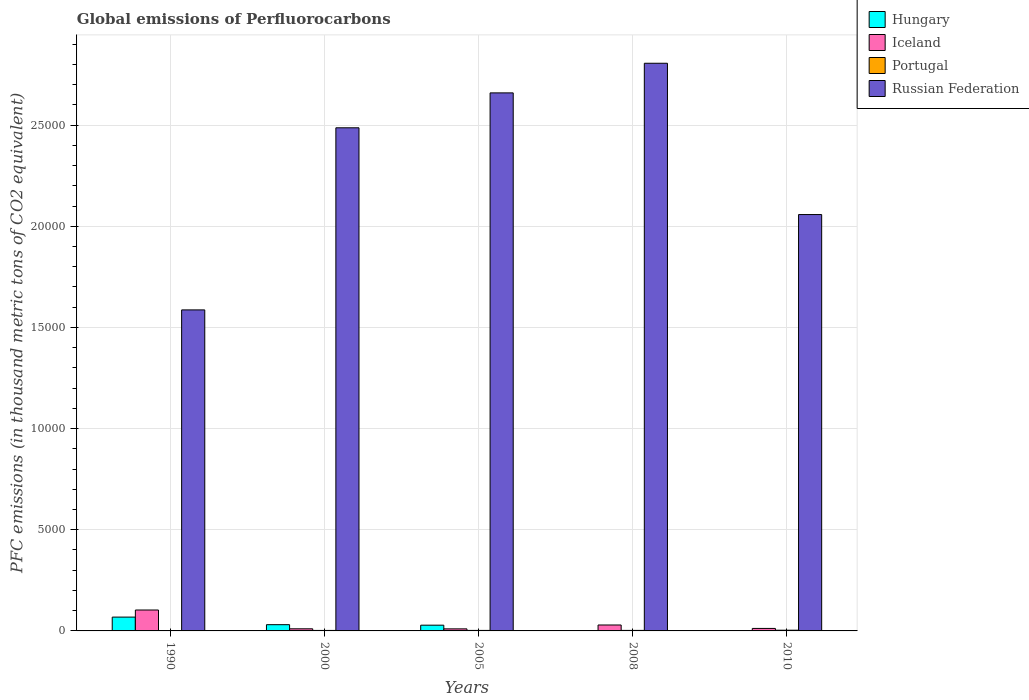How many different coloured bars are there?
Your answer should be compact. 4. How many groups of bars are there?
Offer a terse response. 5. Are the number of bars on each tick of the X-axis equal?
Your response must be concise. Yes. What is the label of the 1st group of bars from the left?
Offer a very short reply. 1990. In how many cases, is the number of bars for a given year not equal to the number of legend labels?
Keep it short and to the point. 0. What is the global emissions of Perfluorocarbons in Portugal in 2005?
Your answer should be very brief. 25.4. Across all years, what is the maximum global emissions of Perfluorocarbons in Russian Federation?
Your response must be concise. 2.81e+04. Across all years, what is the minimum global emissions of Perfluorocarbons in Iceland?
Your answer should be very brief. 101.6. In which year was the global emissions of Perfluorocarbons in Portugal maximum?
Your answer should be compact. 2010. What is the total global emissions of Perfluorocarbons in Russian Federation in the graph?
Provide a succinct answer. 1.16e+05. What is the difference between the global emissions of Perfluorocarbons in Hungary in 2000 and that in 2008?
Give a very brief answer. 305.8. What is the difference between the global emissions of Perfluorocarbons in Iceland in 2000 and the global emissions of Perfluorocarbons in Hungary in 2008?
Your response must be concise. 101.9. What is the average global emissions of Perfluorocarbons in Hungary per year?
Provide a succinct answer. 256.24. In the year 1990, what is the difference between the global emissions of Perfluorocarbons in Iceland and global emissions of Perfluorocarbons in Russian Federation?
Offer a terse response. -1.48e+04. What is the ratio of the global emissions of Perfluorocarbons in Iceland in 2000 to that in 2010?
Provide a short and direct response. 0.85. Is the global emissions of Perfluorocarbons in Hungary in 1990 less than that in 2008?
Offer a terse response. No. Is the difference between the global emissions of Perfluorocarbons in Iceland in 1990 and 2005 greater than the difference between the global emissions of Perfluorocarbons in Russian Federation in 1990 and 2005?
Give a very brief answer. Yes. What is the difference between the highest and the second highest global emissions of Perfluorocarbons in Iceland?
Make the answer very short. 740.7. What is the difference between the highest and the lowest global emissions of Perfluorocarbons in Portugal?
Provide a succinct answer. 32.4. What does the 4th bar from the right in 2005 represents?
Offer a terse response. Hungary. Is it the case that in every year, the sum of the global emissions of Perfluorocarbons in Russian Federation and global emissions of Perfluorocarbons in Iceland is greater than the global emissions of Perfluorocarbons in Hungary?
Offer a very short reply. Yes. How many bars are there?
Your response must be concise. 20. Are all the bars in the graph horizontal?
Your response must be concise. No. Are the values on the major ticks of Y-axis written in scientific E-notation?
Give a very brief answer. No. Does the graph contain any zero values?
Your answer should be very brief. No. Does the graph contain grids?
Offer a terse response. Yes. How many legend labels are there?
Give a very brief answer. 4. How are the legend labels stacked?
Provide a short and direct response. Vertical. What is the title of the graph?
Provide a short and direct response. Global emissions of Perfluorocarbons. What is the label or title of the Y-axis?
Provide a succinct answer. PFC emissions (in thousand metric tons of CO2 equivalent). What is the PFC emissions (in thousand metric tons of CO2 equivalent) in Hungary in 1990?
Provide a short and direct response. 683.3. What is the PFC emissions (in thousand metric tons of CO2 equivalent) of Iceland in 1990?
Your response must be concise. 1033.4. What is the PFC emissions (in thousand metric tons of CO2 equivalent) of Russian Federation in 1990?
Provide a succinct answer. 1.59e+04. What is the PFC emissions (in thousand metric tons of CO2 equivalent) in Hungary in 2000?
Offer a very short reply. 308.5. What is the PFC emissions (in thousand metric tons of CO2 equivalent) in Iceland in 2000?
Your answer should be very brief. 104.6. What is the PFC emissions (in thousand metric tons of CO2 equivalent) in Portugal in 2000?
Your answer should be very brief. 24.6. What is the PFC emissions (in thousand metric tons of CO2 equivalent) of Russian Federation in 2000?
Your answer should be very brief. 2.49e+04. What is the PFC emissions (in thousand metric tons of CO2 equivalent) in Hungary in 2005?
Your answer should be very brief. 283.7. What is the PFC emissions (in thousand metric tons of CO2 equivalent) in Iceland in 2005?
Offer a terse response. 101.6. What is the PFC emissions (in thousand metric tons of CO2 equivalent) in Portugal in 2005?
Provide a short and direct response. 25.4. What is the PFC emissions (in thousand metric tons of CO2 equivalent) in Russian Federation in 2005?
Your answer should be very brief. 2.66e+04. What is the PFC emissions (in thousand metric tons of CO2 equivalent) in Hungary in 2008?
Provide a succinct answer. 2.7. What is the PFC emissions (in thousand metric tons of CO2 equivalent) of Iceland in 2008?
Make the answer very short. 292.7. What is the PFC emissions (in thousand metric tons of CO2 equivalent) in Portugal in 2008?
Your answer should be compact. 25.9. What is the PFC emissions (in thousand metric tons of CO2 equivalent) in Russian Federation in 2008?
Your answer should be very brief. 2.81e+04. What is the PFC emissions (in thousand metric tons of CO2 equivalent) in Iceland in 2010?
Your answer should be compact. 123. What is the PFC emissions (in thousand metric tons of CO2 equivalent) of Russian Federation in 2010?
Your answer should be compact. 2.06e+04. Across all years, what is the maximum PFC emissions (in thousand metric tons of CO2 equivalent) in Hungary?
Provide a succinct answer. 683.3. Across all years, what is the maximum PFC emissions (in thousand metric tons of CO2 equivalent) in Iceland?
Your answer should be very brief. 1033.4. Across all years, what is the maximum PFC emissions (in thousand metric tons of CO2 equivalent) of Portugal?
Provide a short and direct response. 35. Across all years, what is the maximum PFC emissions (in thousand metric tons of CO2 equivalent) in Russian Federation?
Give a very brief answer. 2.81e+04. Across all years, what is the minimum PFC emissions (in thousand metric tons of CO2 equivalent) of Hungary?
Offer a very short reply. 2.7. Across all years, what is the minimum PFC emissions (in thousand metric tons of CO2 equivalent) of Iceland?
Your response must be concise. 101.6. Across all years, what is the minimum PFC emissions (in thousand metric tons of CO2 equivalent) in Portugal?
Make the answer very short. 2.6. Across all years, what is the minimum PFC emissions (in thousand metric tons of CO2 equivalent) of Russian Federation?
Give a very brief answer. 1.59e+04. What is the total PFC emissions (in thousand metric tons of CO2 equivalent) in Hungary in the graph?
Make the answer very short. 1281.2. What is the total PFC emissions (in thousand metric tons of CO2 equivalent) of Iceland in the graph?
Offer a very short reply. 1655.3. What is the total PFC emissions (in thousand metric tons of CO2 equivalent) of Portugal in the graph?
Ensure brevity in your answer.  113.5. What is the total PFC emissions (in thousand metric tons of CO2 equivalent) of Russian Federation in the graph?
Offer a terse response. 1.16e+05. What is the difference between the PFC emissions (in thousand metric tons of CO2 equivalent) in Hungary in 1990 and that in 2000?
Make the answer very short. 374.8. What is the difference between the PFC emissions (in thousand metric tons of CO2 equivalent) in Iceland in 1990 and that in 2000?
Ensure brevity in your answer.  928.8. What is the difference between the PFC emissions (in thousand metric tons of CO2 equivalent) of Portugal in 1990 and that in 2000?
Make the answer very short. -22. What is the difference between the PFC emissions (in thousand metric tons of CO2 equivalent) of Russian Federation in 1990 and that in 2000?
Your answer should be very brief. -8999.9. What is the difference between the PFC emissions (in thousand metric tons of CO2 equivalent) in Hungary in 1990 and that in 2005?
Keep it short and to the point. 399.6. What is the difference between the PFC emissions (in thousand metric tons of CO2 equivalent) of Iceland in 1990 and that in 2005?
Offer a terse response. 931.8. What is the difference between the PFC emissions (in thousand metric tons of CO2 equivalent) in Portugal in 1990 and that in 2005?
Make the answer very short. -22.8. What is the difference between the PFC emissions (in thousand metric tons of CO2 equivalent) in Russian Federation in 1990 and that in 2005?
Provide a short and direct response. -1.07e+04. What is the difference between the PFC emissions (in thousand metric tons of CO2 equivalent) of Hungary in 1990 and that in 2008?
Your answer should be very brief. 680.6. What is the difference between the PFC emissions (in thousand metric tons of CO2 equivalent) in Iceland in 1990 and that in 2008?
Offer a terse response. 740.7. What is the difference between the PFC emissions (in thousand metric tons of CO2 equivalent) of Portugal in 1990 and that in 2008?
Keep it short and to the point. -23.3. What is the difference between the PFC emissions (in thousand metric tons of CO2 equivalent) of Russian Federation in 1990 and that in 2008?
Make the answer very short. -1.22e+04. What is the difference between the PFC emissions (in thousand metric tons of CO2 equivalent) in Hungary in 1990 and that in 2010?
Ensure brevity in your answer.  680.3. What is the difference between the PFC emissions (in thousand metric tons of CO2 equivalent) of Iceland in 1990 and that in 2010?
Give a very brief answer. 910.4. What is the difference between the PFC emissions (in thousand metric tons of CO2 equivalent) in Portugal in 1990 and that in 2010?
Offer a terse response. -32.4. What is the difference between the PFC emissions (in thousand metric tons of CO2 equivalent) in Russian Federation in 1990 and that in 2010?
Offer a very short reply. -4711.8. What is the difference between the PFC emissions (in thousand metric tons of CO2 equivalent) of Hungary in 2000 and that in 2005?
Your answer should be very brief. 24.8. What is the difference between the PFC emissions (in thousand metric tons of CO2 equivalent) in Iceland in 2000 and that in 2005?
Provide a succinct answer. 3. What is the difference between the PFC emissions (in thousand metric tons of CO2 equivalent) in Russian Federation in 2000 and that in 2005?
Offer a terse response. -1725.2. What is the difference between the PFC emissions (in thousand metric tons of CO2 equivalent) in Hungary in 2000 and that in 2008?
Give a very brief answer. 305.8. What is the difference between the PFC emissions (in thousand metric tons of CO2 equivalent) in Iceland in 2000 and that in 2008?
Offer a terse response. -188.1. What is the difference between the PFC emissions (in thousand metric tons of CO2 equivalent) in Russian Federation in 2000 and that in 2008?
Give a very brief answer. -3189.7. What is the difference between the PFC emissions (in thousand metric tons of CO2 equivalent) of Hungary in 2000 and that in 2010?
Keep it short and to the point. 305.5. What is the difference between the PFC emissions (in thousand metric tons of CO2 equivalent) of Iceland in 2000 and that in 2010?
Your response must be concise. -18.4. What is the difference between the PFC emissions (in thousand metric tons of CO2 equivalent) in Russian Federation in 2000 and that in 2010?
Provide a short and direct response. 4288.1. What is the difference between the PFC emissions (in thousand metric tons of CO2 equivalent) in Hungary in 2005 and that in 2008?
Make the answer very short. 281. What is the difference between the PFC emissions (in thousand metric tons of CO2 equivalent) in Iceland in 2005 and that in 2008?
Keep it short and to the point. -191.1. What is the difference between the PFC emissions (in thousand metric tons of CO2 equivalent) of Portugal in 2005 and that in 2008?
Ensure brevity in your answer.  -0.5. What is the difference between the PFC emissions (in thousand metric tons of CO2 equivalent) in Russian Federation in 2005 and that in 2008?
Make the answer very short. -1464.5. What is the difference between the PFC emissions (in thousand metric tons of CO2 equivalent) in Hungary in 2005 and that in 2010?
Your answer should be compact. 280.7. What is the difference between the PFC emissions (in thousand metric tons of CO2 equivalent) of Iceland in 2005 and that in 2010?
Provide a succinct answer. -21.4. What is the difference between the PFC emissions (in thousand metric tons of CO2 equivalent) of Russian Federation in 2005 and that in 2010?
Your response must be concise. 6013.3. What is the difference between the PFC emissions (in thousand metric tons of CO2 equivalent) in Hungary in 2008 and that in 2010?
Keep it short and to the point. -0.3. What is the difference between the PFC emissions (in thousand metric tons of CO2 equivalent) in Iceland in 2008 and that in 2010?
Make the answer very short. 169.7. What is the difference between the PFC emissions (in thousand metric tons of CO2 equivalent) in Russian Federation in 2008 and that in 2010?
Provide a short and direct response. 7477.8. What is the difference between the PFC emissions (in thousand metric tons of CO2 equivalent) of Hungary in 1990 and the PFC emissions (in thousand metric tons of CO2 equivalent) of Iceland in 2000?
Make the answer very short. 578.7. What is the difference between the PFC emissions (in thousand metric tons of CO2 equivalent) in Hungary in 1990 and the PFC emissions (in thousand metric tons of CO2 equivalent) in Portugal in 2000?
Make the answer very short. 658.7. What is the difference between the PFC emissions (in thousand metric tons of CO2 equivalent) in Hungary in 1990 and the PFC emissions (in thousand metric tons of CO2 equivalent) in Russian Federation in 2000?
Provide a short and direct response. -2.42e+04. What is the difference between the PFC emissions (in thousand metric tons of CO2 equivalent) in Iceland in 1990 and the PFC emissions (in thousand metric tons of CO2 equivalent) in Portugal in 2000?
Keep it short and to the point. 1008.8. What is the difference between the PFC emissions (in thousand metric tons of CO2 equivalent) of Iceland in 1990 and the PFC emissions (in thousand metric tons of CO2 equivalent) of Russian Federation in 2000?
Give a very brief answer. -2.38e+04. What is the difference between the PFC emissions (in thousand metric tons of CO2 equivalent) of Portugal in 1990 and the PFC emissions (in thousand metric tons of CO2 equivalent) of Russian Federation in 2000?
Your response must be concise. -2.49e+04. What is the difference between the PFC emissions (in thousand metric tons of CO2 equivalent) of Hungary in 1990 and the PFC emissions (in thousand metric tons of CO2 equivalent) of Iceland in 2005?
Give a very brief answer. 581.7. What is the difference between the PFC emissions (in thousand metric tons of CO2 equivalent) of Hungary in 1990 and the PFC emissions (in thousand metric tons of CO2 equivalent) of Portugal in 2005?
Your answer should be compact. 657.9. What is the difference between the PFC emissions (in thousand metric tons of CO2 equivalent) in Hungary in 1990 and the PFC emissions (in thousand metric tons of CO2 equivalent) in Russian Federation in 2005?
Keep it short and to the point. -2.59e+04. What is the difference between the PFC emissions (in thousand metric tons of CO2 equivalent) in Iceland in 1990 and the PFC emissions (in thousand metric tons of CO2 equivalent) in Portugal in 2005?
Ensure brevity in your answer.  1008. What is the difference between the PFC emissions (in thousand metric tons of CO2 equivalent) of Iceland in 1990 and the PFC emissions (in thousand metric tons of CO2 equivalent) of Russian Federation in 2005?
Give a very brief answer. -2.56e+04. What is the difference between the PFC emissions (in thousand metric tons of CO2 equivalent) in Portugal in 1990 and the PFC emissions (in thousand metric tons of CO2 equivalent) in Russian Federation in 2005?
Your answer should be very brief. -2.66e+04. What is the difference between the PFC emissions (in thousand metric tons of CO2 equivalent) of Hungary in 1990 and the PFC emissions (in thousand metric tons of CO2 equivalent) of Iceland in 2008?
Provide a succinct answer. 390.6. What is the difference between the PFC emissions (in thousand metric tons of CO2 equivalent) in Hungary in 1990 and the PFC emissions (in thousand metric tons of CO2 equivalent) in Portugal in 2008?
Offer a very short reply. 657.4. What is the difference between the PFC emissions (in thousand metric tons of CO2 equivalent) of Hungary in 1990 and the PFC emissions (in thousand metric tons of CO2 equivalent) of Russian Federation in 2008?
Your answer should be compact. -2.74e+04. What is the difference between the PFC emissions (in thousand metric tons of CO2 equivalent) in Iceland in 1990 and the PFC emissions (in thousand metric tons of CO2 equivalent) in Portugal in 2008?
Your response must be concise. 1007.5. What is the difference between the PFC emissions (in thousand metric tons of CO2 equivalent) of Iceland in 1990 and the PFC emissions (in thousand metric tons of CO2 equivalent) of Russian Federation in 2008?
Make the answer very short. -2.70e+04. What is the difference between the PFC emissions (in thousand metric tons of CO2 equivalent) in Portugal in 1990 and the PFC emissions (in thousand metric tons of CO2 equivalent) in Russian Federation in 2008?
Your response must be concise. -2.81e+04. What is the difference between the PFC emissions (in thousand metric tons of CO2 equivalent) of Hungary in 1990 and the PFC emissions (in thousand metric tons of CO2 equivalent) of Iceland in 2010?
Your response must be concise. 560.3. What is the difference between the PFC emissions (in thousand metric tons of CO2 equivalent) in Hungary in 1990 and the PFC emissions (in thousand metric tons of CO2 equivalent) in Portugal in 2010?
Offer a very short reply. 648.3. What is the difference between the PFC emissions (in thousand metric tons of CO2 equivalent) of Hungary in 1990 and the PFC emissions (in thousand metric tons of CO2 equivalent) of Russian Federation in 2010?
Offer a very short reply. -1.99e+04. What is the difference between the PFC emissions (in thousand metric tons of CO2 equivalent) in Iceland in 1990 and the PFC emissions (in thousand metric tons of CO2 equivalent) in Portugal in 2010?
Provide a succinct answer. 998.4. What is the difference between the PFC emissions (in thousand metric tons of CO2 equivalent) in Iceland in 1990 and the PFC emissions (in thousand metric tons of CO2 equivalent) in Russian Federation in 2010?
Your answer should be very brief. -1.95e+04. What is the difference between the PFC emissions (in thousand metric tons of CO2 equivalent) in Portugal in 1990 and the PFC emissions (in thousand metric tons of CO2 equivalent) in Russian Federation in 2010?
Your answer should be very brief. -2.06e+04. What is the difference between the PFC emissions (in thousand metric tons of CO2 equivalent) in Hungary in 2000 and the PFC emissions (in thousand metric tons of CO2 equivalent) in Iceland in 2005?
Your answer should be very brief. 206.9. What is the difference between the PFC emissions (in thousand metric tons of CO2 equivalent) in Hungary in 2000 and the PFC emissions (in thousand metric tons of CO2 equivalent) in Portugal in 2005?
Offer a terse response. 283.1. What is the difference between the PFC emissions (in thousand metric tons of CO2 equivalent) of Hungary in 2000 and the PFC emissions (in thousand metric tons of CO2 equivalent) of Russian Federation in 2005?
Ensure brevity in your answer.  -2.63e+04. What is the difference between the PFC emissions (in thousand metric tons of CO2 equivalent) of Iceland in 2000 and the PFC emissions (in thousand metric tons of CO2 equivalent) of Portugal in 2005?
Your answer should be compact. 79.2. What is the difference between the PFC emissions (in thousand metric tons of CO2 equivalent) in Iceland in 2000 and the PFC emissions (in thousand metric tons of CO2 equivalent) in Russian Federation in 2005?
Provide a short and direct response. -2.65e+04. What is the difference between the PFC emissions (in thousand metric tons of CO2 equivalent) in Portugal in 2000 and the PFC emissions (in thousand metric tons of CO2 equivalent) in Russian Federation in 2005?
Provide a succinct answer. -2.66e+04. What is the difference between the PFC emissions (in thousand metric tons of CO2 equivalent) of Hungary in 2000 and the PFC emissions (in thousand metric tons of CO2 equivalent) of Portugal in 2008?
Provide a short and direct response. 282.6. What is the difference between the PFC emissions (in thousand metric tons of CO2 equivalent) of Hungary in 2000 and the PFC emissions (in thousand metric tons of CO2 equivalent) of Russian Federation in 2008?
Make the answer very short. -2.77e+04. What is the difference between the PFC emissions (in thousand metric tons of CO2 equivalent) of Iceland in 2000 and the PFC emissions (in thousand metric tons of CO2 equivalent) of Portugal in 2008?
Make the answer very short. 78.7. What is the difference between the PFC emissions (in thousand metric tons of CO2 equivalent) of Iceland in 2000 and the PFC emissions (in thousand metric tons of CO2 equivalent) of Russian Federation in 2008?
Provide a succinct answer. -2.80e+04. What is the difference between the PFC emissions (in thousand metric tons of CO2 equivalent) of Portugal in 2000 and the PFC emissions (in thousand metric tons of CO2 equivalent) of Russian Federation in 2008?
Provide a succinct answer. -2.80e+04. What is the difference between the PFC emissions (in thousand metric tons of CO2 equivalent) of Hungary in 2000 and the PFC emissions (in thousand metric tons of CO2 equivalent) of Iceland in 2010?
Offer a very short reply. 185.5. What is the difference between the PFC emissions (in thousand metric tons of CO2 equivalent) of Hungary in 2000 and the PFC emissions (in thousand metric tons of CO2 equivalent) of Portugal in 2010?
Your answer should be very brief. 273.5. What is the difference between the PFC emissions (in thousand metric tons of CO2 equivalent) in Hungary in 2000 and the PFC emissions (in thousand metric tons of CO2 equivalent) in Russian Federation in 2010?
Give a very brief answer. -2.03e+04. What is the difference between the PFC emissions (in thousand metric tons of CO2 equivalent) in Iceland in 2000 and the PFC emissions (in thousand metric tons of CO2 equivalent) in Portugal in 2010?
Your answer should be very brief. 69.6. What is the difference between the PFC emissions (in thousand metric tons of CO2 equivalent) of Iceland in 2000 and the PFC emissions (in thousand metric tons of CO2 equivalent) of Russian Federation in 2010?
Your response must be concise. -2.05e+04. What is the difference between the PFC emissions (in thousand metric tons of CO2 equivalent) of Portugal in 2000 and the PFC emissions (in thousand metric tons of CO2 equivalent) of Russian Federation in 2010?
Your answer should be compact. -2.06e+04. What is the difference between the PFC emissions (in thousand metric tons of CO2 equivalent) of Hungary in 2005 and the PFC emissions (in thousand metric tons of CO2 equivalent) of Iceland in 2008?
Provide a short and direct response. -9. What is the difference between the PFC emissions (in thousand metric tons of CO2 equivalent) in Hungary in 2005 and the PFC emissions (in thousand metric tons of CO2 equivalent) in Portugal in 2008?
Ensure brevity in your answer.  257.8. What is the difference between the PFC emissions (in thousand metric tons of CO2 equivalent) of Hungary in 2005 and the PFC emissions (in thousand metric tons of CO2 equivalent) of Russian Federation in 2008?
Your answer should be compact. -2.78e+04. What is the difference between the PFC emissions (in thousand metric tons of CO2 equivalent) of Iceland in 2005 and the PFC emissions (in thousand metric tons of CO2 equivalent) of Portugal in 2008?
Your answer should be compact. 75.7. What is the difference between the PFC emissions (in thousand metric tons of CO2 equivalent) in Iceland in 2005 and the PFC emissions (in thousand metric tons of CO2 equivalent) in Russian Federation in 2008?
Offer a very short reply. -2.80e+04. What is the difference between the PFC emissions (in thousand metric tons of CO2 equivalent) of Portugal in 2005 and the PFC emissions (in thousand metric tons of CO2 equivalent) of Russian Federation in 2008?
Ensure brevity in your answer.  -2.80e+04. What is the difference between the PFC emissions (in thousand metric tons of CO2 equivalent) in Hungary in 2005 and the PFC emissions (in thousand metric tons of CO2 equivalent) in Iceland in 2010?
Your response must be concise. 160.7. What is the difference between the PFC emissions (in thousand metric tons of CO2 equivalent) in Hungary in 2005 and the PFC emissions (in thousand metric tons of CO2 equivalent) in Portugal in 2010?
Offer a terse response. 248.7. What is the difference between the PFC emissions (in thousand metric tons of CO2 equivalent) of Hungary in 2005 and the PFC emissions (in thousand metric tons of CO2 equivalent) of Russian Federation in 2010?
Offer a terse response. -2.03e+04. What is the difference between the PFC emissions (in thousand metric tons of CO2 equivalent) of Iceland in 2005 and the PFC emissions (in thousand metric tons of CO2 equivalent) of Portugal in 2010?
Offer a very short reply. 66.6. What is the difference between the PFC emissions (in thousand metric tons of CO2 equivalent) of Iceland in 2005 and the PFC emissions (in thousand metric tons of CO2 equivalent) of Russian Federation in 2010?
Keep it short and to the point. -2.05e+04. What is the difference between the PFC emissions (in thousand metric tons of CO2 equivalent) of Portugal in 2005 and the PFC emissions (in thousand metric tons of CO2 equivalent) of Russian Federation in 2010?
Offer a terse response. -2.06e+04. What is the difference between the PFC emissions (in thousand metric tons of CO2 equivalent) in Hungary in 2008 and the PFC emissions (in thousand metric tons of CO2 equivalent) in Iceland in 2010?
Provide a succinct answer. -120.3. What is the difference between the PFC emissions (in thousand metric tons of CO2 equivalent) in Hungary in 2008 and the PFC emissions (in thousand metric tons of CO2 equivalent) in Portugal in 2010?
Provide a succinct answer. -32.3. What is the difference between the PFC emissions (in thousand metric tons of CO2 equivalent) in Hungary in 2008 and the PFC emissions (in thousand metric tons of CO2 equivalent) in Russian Federation in 2010?
Provide a succinct answer. -2.06e+04. What is the difference between the PFC emissions (in thousand metric tons of CO2 equivalent) of Iceland in 2008 and the PFC emissions (in thousand metric tons of CO2 equivalent) of Portugal in 2010?
Keep it short and to the point. 257.7. What is the difference between the PFC emissions (in thousand metric tons of CO2 equivalent) of Iceland in 2008 and the PFC emissions (in thousand metric tons of CO2 equivalent) of Russian Federation in 2010?
Provide a succinct answer. -2.03e+04. What is the difference between the PFC emissions (in thousand metric tons of CO2 equivalent) in Portugal in 2008 and the PFC emissions (in thousand metric tons of CO2 equivalent) in Russian Federation in 2010?
Keep it short and to the point. -2.06e+04. What is the average PFC emissions (in thousand metric tons of CO2 equivalent) in Hungary per year?
Keep it short and to the point. 256.24. What is the average PFC emissions (in thousand metric tons of CO2 equivalent) of Iceland per year?
Your response must be concise. 331.06. What is the average PFC emissions (in thousand metric tons of CO2 equivalent) in Portugal per year?
Your response must be concise. 22.7. What is the average PFC emissions (in thousand metric tons of CO2 equivalent) of Russian Federation per year?
Provide a succinct answer. 2.32e+04. In the year 1990, what is the difference between the PFC emissions (in thousand metric tons of CO2 equivalent) in Hungary and PFC emissions (in thousand metric tons of CO2 equivalent) in Iceland?
Provide a short and direct response. -350.1. In the year 1990, what is the difference between the PFC emissions (in thousand metric tons of CO2 equivalent) in Hungary and PFC emissions (in thousand metric tons of CO2 equivalent) in Portugal?
Keep it short and to the point. 680.7. In the year 1990, what is the difference between the PFC emissions (in thousand metric tons of CO2 equivalent) of Hungary and PFC emissions (in thousand metric tons of CO2 equivalent) of Russian Federation?
Ensure brevity in your answer.  -1.52e+04. In the year 1990, what is the difference between the PFC emissions (in thousand metric tons of CO2 equivalent) in Iceland and PFC emissions (in thousand metric tons of CO2 equivalent) in Portugal?
Your response must be concise. 1030.8. In the year 1990, what is the difference between the PFC emissions (in thousand metric tons of CO2 equivalent) in Iceland and PFC emissions (in thousand metric tons of CO2 equivalent) in Russian Federation?
Your response must be concise. -1.48e+04. In the year 1990, what is the difference between the PFC emissions (in thousand metric tons of CO2 equivalent) in Portugal and PFC emissions (in thousand metric tons of CO2 equivalent) in Russian Federation?
Provide a short and direct response. -1.59e+04. In the year 2000, what is the difference between the PFC emissions (in thousand metric tons of CO2 equivalent) in Hungary and PFC emissions (in thousand metric tons of CO2 equivalent) in Iceland?
Offer a terse response. 203.9. In the year 2000, what is the difference between the PFC emissions (in thousand metric tons of CO2 equivalent) in Hungary and PFC emissions (in thousand metric tons of CO2 equivalent) in Portugal?
Provide a succinct answer. 283.9. In the year 2000, what is the difference between the PFC emissions (in thousand metric tons of CO2 equivalent) in Hungary and PFC emissions (in thousand metric tons of CO2 equivalent) in Russian Federation?
Your answer should be very brief. -2.46e+04. In the year 2000, what is the difference between the PFC emissions (in thousand metric tons of CO2 equivalent) in Iceland and PFC emissions (in thousand metric tons of CO2 equivalent) in Portugal?
Keep it short and to the point. 80. In the year 2000, what is the difference between the PFC emissions (in thousand metric tons of CO2 equivalent) of Iceland and PFC emissions (in thousand metric tons of CO2 equivalent) of Russian Federation?
Offer a terse response. -2.48e+04. In the year 2000, what is the difference between the PFC emissions (in thousand metric tons of CO2 equivalent) of Portugal and PFC emissions (in thousand metric tons of CO2 equivalent) of Russian Federation?
Offer a very short reply. -2.48e+04. In the year 2005, what is the difference between the PFC emissions (in thousand metric tons of CO2 equivalent) of Hungary and PFC emissions (in thousand metric tons of CO2 equivalent) of Iceland?
Ensure brevity in your answer.  182.1. In the year 2005, what is the difference between the PFC emissions (in thousand metric tons of CO2 equivalent) of Hungary and PFC emissions (in thousand metric tons of CO2 equivalent) of Portugal?
Provide a short and direct response. 258.3. In the year 2005, what is the difference between the PFC emissions (in thousand metric tons of CO2 equivalent) in Hungary and PFC emissions (in thousand metric tons of CO2 equivalent) in Russian Federation?
Keep it short and to the point. -2.63e+04. In the year 2005, what is the difference between the PFC emissions (in thousand metric tons of CO2 equivalent) of Iceland and PFC emissions (in thousand metric tons of CO2 equivalent) of Portugal?
Provide a short and direct response. 76.2. In the year 2005, what is the difference between the PFC emissions (in thousand metric tons of CO2 equivalent) in Iceland and PFC emissions (in thousand metric tons of CO2 equivalent) in Russian Federation?
Ensure brevity in your answer.  -2.65e+04. In the year 2005, what is the difference between the PFC emissions (in thousand metric tons of CO2 equivalent) of Portugal and PFC emissions (in thousand metric tons of CO2 equivalent) of Russian Federation?
Keep it short and to the point. -2.66e+04. In the year 2008, what is the difference between the PFC emissions (in thousand metric tons of CO2 equivalent) in Hungary and PFC emissions (in thousand metric tons of CO2 equivalent) in Iceland?
Your answer should be compact. -290. In the year 2008, what is the difference between the PFC emissions (in thousand metric tons of CO2 equivalent) in Hungary and PFC emissions (in thousand metric tons of CO2 equivalent) in Portugal?
Provide a succinct answer. -23.2. In the year 2008, what is the difference between the PFC emissions (in thousand metric tons of CO2 equivalent) of Hungary and PFC emissions (in thousand metric tons of CO2 equivalent) of Russian Federation?
Provide a succinct answer. -2.81e+04. In the year 2008, what is the difference between the PFC emissions (in thousand metric tons of CO2 equivalent) of Iceland and PFC emissions (in thousand metric tons of CO2 equivalent) of Portugal?
Keep it short and to the point. 266.8. In the year 2008, what is the difference between the PFC emissions (in thousand metric tons of CO2 equivalent) in Iceland and PFC emissions (in thousand metric tons of CO2 equivalent) in Russian Federation?
Keep it short and to the point. -2.78e+04. In the year 2008, what is the difference between the PFC emissions (in thousand metric tons of CO2 equivalent) of Portugal and PFC emissions (in thousand metric tons of CO2 equivalent) of Russian Federation?
Ensure brevity in your answer.  -2.80e+04. In the year 2010, what is the difference between the PFC emissions (in thousand metric tons of CO2 equivalent) of Hungary and PFC emissions (in thousand metric tons of CO2 equivalent) of Iceland?
Offer a very short reply. -120. In the year 2010, what is the difference between the PFC emissions (in thousand metric tons of CO2 equivalent) in Hungary and PFC emissions (in thousand metric tons of CO2 equivalent) in Portugal?
Offer a terse response. -32. In the year 2010, what is the difference between the PFC emissions (in thousand metric tons of CO2 equivalent) of Hungary and PFC emissions (in thousand metric tons of CO2 equivalent) of Russian Federation?
Offer a very short reply. -2.06e+04. In the year 2010, what is the difference between the PFC emissions (in thousand metric tons of CO2 equivalent) of Iceland and PFC emissions (in thousand metric tons of CO2 equivalent) of Russian Federation?
Your response must be concise. -2.05e+04. In the year 2010, what is the difference between the PFC emissions (in thousand metric tons of CO2 equivalent) in Portugal and PFC emissions (in thousand metric tons of CO2 equivalent) in Russian Federation?
Make the answer very short. -2.05e+04. What is the ratio of the PFC emissions (in thousand metric tons of CO2 equivalent) of Hungary in 1990 to that in 2000?
Your answer should be compact. 2.21. What is the ratio of the PFC emissions (in thousand metric tons of CO2 equivalent) in Iceland in 1990 to that in 2000?
Provide a succinct answer. 9.88. What is the ratio of the PFC emissions (in thousand metric tons of CO2 equivalent) of Portugal in 1990 to that in 2000?
Provide a short and direct response. 0.11. What is the ratio of the PFC emissions (in thousand metric tons of CO2 equivalent) in Russian Federation in 1990 to that in 2000?
Give a very brief answer. 0.64. What is the ratio of the PFC emissions (in thousand metric tons of CO2 equivalent) of Hungary in 1990 to that in 2005?
Make the answer very short. 2.41. What is the ratio of the PFC emissions (in thousand metric tons of CO2 equivalent) in Iceland in 1990 to that in 2005?
Make the answer very short. 10.17. What is the ratio of the PFC emissions (in thousand metric tons of CO2 equivalent) in Portugal in 1990 to that in 2005?
Offer a terse response. 0.1. What is the ratio of the PFC emissions (in thousand metric tons of CO2 equivalent) of Russian Federation in 1990 to that in 2005?
Your answer should be very brief. 0.6. What is the ratio of the PFC emissions (in thousand metric tons of CO2 equivalent) in Hungary in 1990 to that in 2008?
Keep it short and to the point. 253.07. What is the ratio of the PFC emissions (in thousand metric tons of CO2 equivalent) of Iceland in 1990 to that in 2008?
Ensure brevity in your answer.  3.53. What is the ratio of the PFC emissions (in thousand metric tons of CO2 equivalent) of Portugal in 1990 to that in 2008?
Your response must be concise. 0.1. What is the ratio of the PFC emissions (in thousand metric tons of CO2 equivalent) of Russian Federation in 1990 to that in 2008?
Offer a terse response. 0.57. What is the ratio of the PFC emissions (in thousand metric tons of CO2 equivalent) of Hungary in 1990 to that in 2010?
Keep it short and to the point. 227.77. What is the ratio of the PFC emissions (in thousand metric tons of CO2 equivalent) of Iceland in 1990 to that in 2010?
Offer a very short reply. 8.4. What is the ratio of the PFC emissions (in thousand metric tons of CO2 equivalent) in Portugal in 1990 to that in 2010?
Offer a very short reply. 0.07. What is the ratio of the PFC emissions (in thousand metric tons of CO2 equivalent) of Russian Federation in 1990 to that in 2010?
Provide a succinct answer. 0.77. What is the ratio of the PFC emissions (in thousand metric tons of CO2 equivalent) of Hungary in 2000 to that in 2005?
Keep it short and to the point. 1.09. What is the ratio of the PFC emissions (in thousand metric tons of CO2 equivalent) in Iceland in 2000 to that in 2005?
Offer a terse response. 1.03. What is the ratio of the PFC emissions (in thousand metric tons of CO2 equivalent) in Portugal in 2000 to that in 2005?
Your response must be concise. 0.97. What is the ratio of the PFC emissions (in thousand metric tons of CO2 equivalent) in Russian Federation in 2000 to that in 2005?
Keep it short and to the point. 0.94. What is the ratio of the PFC emissions (in thousand metric tons of CO2 equivalent) of Hungary in 2000 to that in 2008?
Give a very brief answer. 114.26. What is the ratio of the PFC emissions (in thousand metric tons of CO2 equivalent) in Iceland in 2000 to that in 2008?
Ensure brevity in your answer.  0.36. What is the ratio of the PFC emissions (in thousand metric tons of CO2 equivalent) in Portugal in 2000 to that in 2008?
Your answer should be compact. 0.95. What is the ratio of the PFC emissions (in thousand metric tons of CO2 equivalent) of Russian Federation in 2000 to that in 2008?
Offer a very short reply. 0.89. What is the ratio of the PFC emissions (in thousand metric tons of CO2 equivalent) in Hungary in 2000 to that in 2010?
Your response must be concise. 102.83. What is the ratio of the PFC emissions (in thousand metric tons of CO2 equivalent) in Iceland in 2000 to that in 2010?
Your response must be concise. 0.85. What is the ratio of the PFC emissions (in thousand metric tons of CO2 equivalent) of Portugal in 2000 to that in 2010?
Make the answer very short. 0.7. What is the ratio of the PFC emissions (in thousand metric tons of CO2 equivalent) of Russian Federation in 2000 to that in 2010?
Your answer should be compact. 1.21. What is the ratio of the PFC emissions (in thousand metric tons of CO2 equivalent) of Hungary in 2005 to that in 2008?
Ensure brevity in your answer.  105.07. What is the ratio of the PFC emissions (in thousand metric tons of CO2 equivalent) of Iceland in 2005 to that in 2008?
Ensure brevity in your answer.  0.35. What is the ratio of the PFC emissions (in thousand metric tons of CO2 equivalent) of Portugal in 2005 to that in 2008?
Ensure brevity in your answer.  0.98. What is the ratio of the PFC emissions (in thousand metric tons of CO2 equivalent) in Russian Federation in 2005 to that in 2008?
Offer a terse response. 0.95. What is the ratio of the PFC emissions (in thousand metric tons of CO2 equivalent) of Hungary in 2005 to that in 2010?
Offer a terse response. 94.57. What is the ratio of the PFC emissions (in thousand metric tons of CO2 equivalent) of Iceland in 2005 to that in 2010?
Offer a very short reply. 0.83. What is the ratio of the PFC emissions (in thousand metric tons of CO2 equivalent) in Portugal in 2005 to that in 2010?
Provide a succinct answer. 0.73. What is the ratio of the PFC emissions (in thousand metric tons of CO2 equivalent) of Russian Federation in 2005 to that in 2010?
Your answer should be compact. 1.29. What is the ratio of the PFC emissions (in thousand metric tons of CO2 equivalent) in Iceland in 2008 to that in 2010?
Your answer should be very brief. 2.38. What is the ratio of the PFC emissions (in thousand metric tons of CO2 equivalent) in Portugal in 2008 to that in 2010?
Offer a very short reply. 0.74. What is the ratio of the PFC emissions (in thousand metric tons of CO2 equivalent) of Russian Federation in 2008 to that in 2010?
Provide a succinct answer. 1.36. What is the difference between the highest and the second highest PFC emissions (in thousand metric tons of CO2 equivalent) in Hungary?
Offer a very short reply. 374.8. What is the difference between the highest and the second highest PFC emissions (in thousand metric tons of CO2 equivalent) in Iceland?
Keep it short and to the point. 740.7. What is the difference between the highest and the second highest PFC emissions (in thousand metric tons of CO2 equivalent) of Portugal?
Offer a very short reply. 9.1. What is the difference between the highest and the second highest PFC emissions (in thousand metric tons of CO2 equivalent) of Russian Federation?
Ensure brevity in your answer.  1464.5. What is the difference between the highest and the lowest PFC emissions (in thousand metric tons of CO2 equivalent) of Hungary?
Your answer should be very brief. 680.6. What is the difference between the highest and the lowest PFC emissions (in thousand metric tons of CO2 equivalent) of Iceland?
Provide a succinct answer. 931.8. What is the difference between the highest and the lowest PFC emissions (in thousand metric tons of CO2 equivalent) in Portugal?
Give a very brief answer. 32.4. What is the difference between the highest and the lowest PFC emissions (in thousand metric tons of CO2 equivalent) in Russian Federation?
Ensure brevity in your answer.  1.22e+04. 